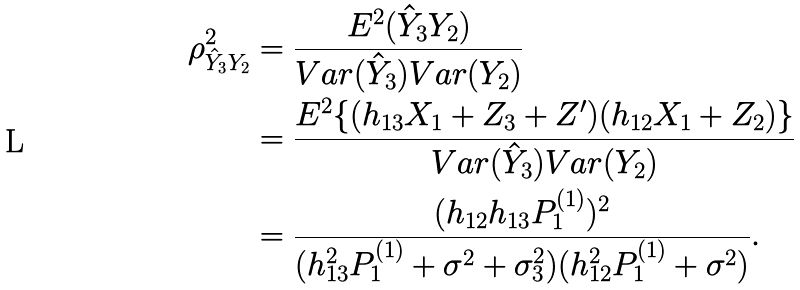Convert formula to latex. <formula><loc_0><loc_0><loc_500><loc_500>\rho _ { \hat { Y } _ { 3 } Y _ { 2 } } ^ { 2 } & = \frac { E ^ { 2 } ( \hat { Y } _ { 3 } Y _ { 2 } ) } { V a r ( \hat { Y } _ { 3 } ) V a r ( Y _ { 2 } ) } \\ & = \frac { E ^ { 2 } \{ ( h _ { 1 3 } X _ { 1 } + Z _ { 3 } + Z ^ { \prime } ) ( h _ { 1 2 } X _ { 1 } + Z _ { 2 } ) \} } { V a r ( \hat { Y } _ { 3 } ) V a r ( Y _ { 2 } ) } \\ & = \frac { ( h _ { 1 2 } h _ { 1 3 } P _ { 1 } ^ { ( 1 ) } ) ^ { 2 } } { ( h _ { 1 3 } ^ { 2 } P _ { 1 } ^ { ( 1 ) } + \sigma ^ { 2 } + \sigma _ { 3 } ^ { 2 } ) ( h _ { 1 2 } ^ { 2 } P _ { 1 } ^ { ( 1 ) } + \sigma ^ { 2 } ) } .</formula> 